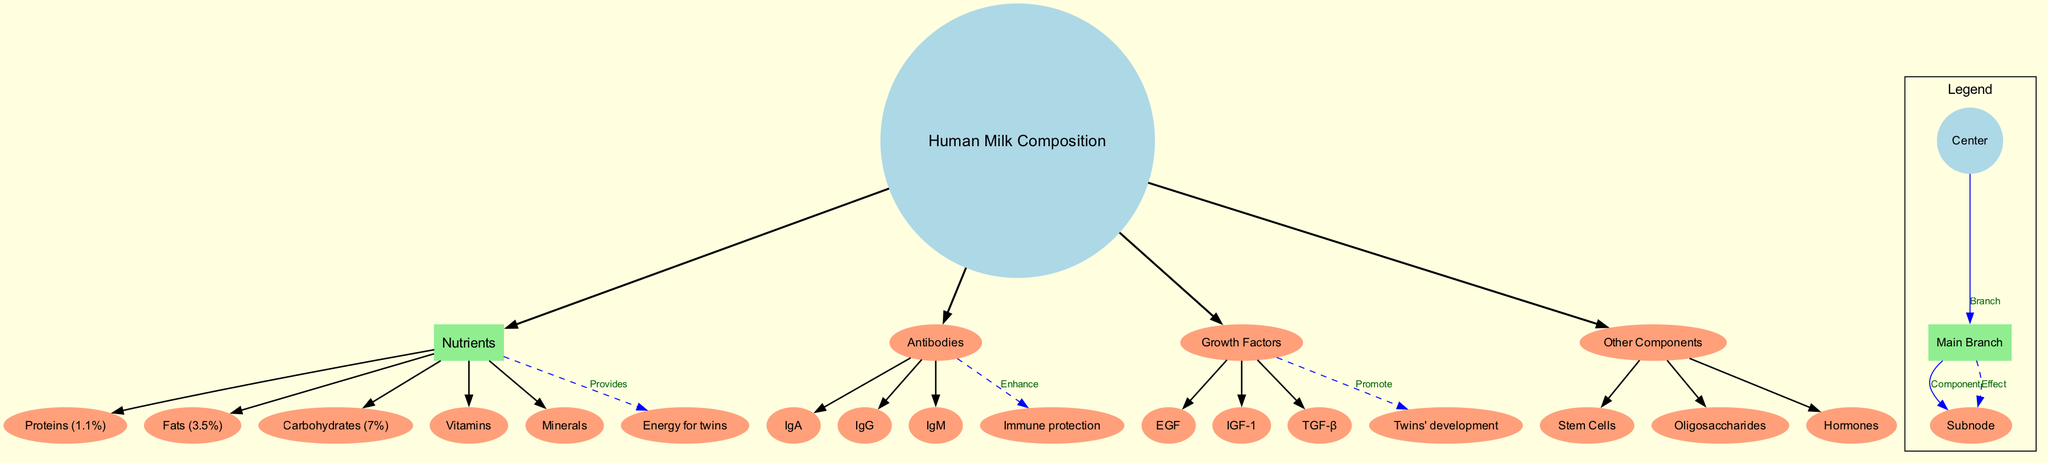What are the percentages of proteins in human milk? The diagram indicates that proteins make up 1.1% of human milk composition. This value is located under the "Nutrients" branch.
Answer: 1.1% What component enhances immune protection? According to the diagram, antibodies are shown to enhance immune protection. This is connected to the "Antibodies" node, emphasizing its role.
Answer: Antibodies How many different antibodies are listed? When examining the "Antibodies" branch on the diagram, three specific antibodies: IgA, IgG, and IgM, are identified. Counting these gives a total of three.
Answer: 3 What are the subnodes under Nutrients? The subnodes listed under the "Nutrients" branch include proteins, fats, carbohydrates, vitamins, and minerals. This information is directly available under the nutrients section.
Answer: Proteins, Fats, Carbohydrates, Vitamins, Minerals Which component promotes the twins' development? The diagram connects growth factors to twins' development and indicates their role in this process. The specific subnodes for growth factors are also listed in this section.
Answer: Growth Factors What percentage of human milk composition is made up of fats? The diagram specifies that fats account for 3.5% of the human milk composition and identifies this value in the "Nutrients" branch.
Answer: 3.5% Which growth factor is listed first in the diagram? The diagram lists EGF (Epidermal Growth Factor) at the beginning under the "Growth Factors" branch, establishing it as the first growth factor mentioned.
Answer: EGF How are carbohydrates represented in human milk composition? Carbohydrates are represented as 7% of the human milk composition, which is clearly indicated under the "Nutrients" branch of the diagram.
Answer: 7% 